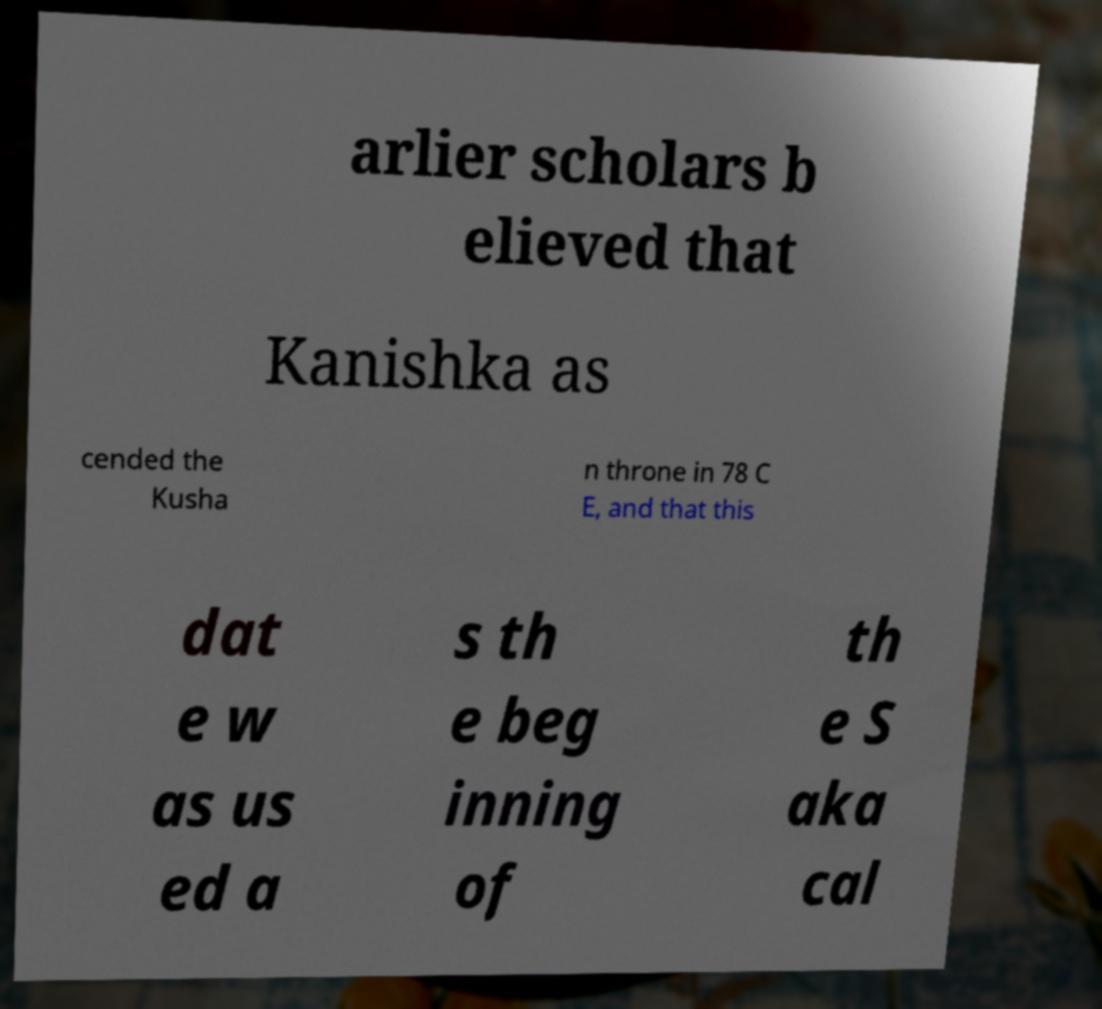Can you accurately transcribe the text from the provided image for me? arlier scholars b elieved that Kanishka as cended the Kusha n throne in 78 C E, and that this dat e w as us ed a s th e beg inning of th e S aka cal 